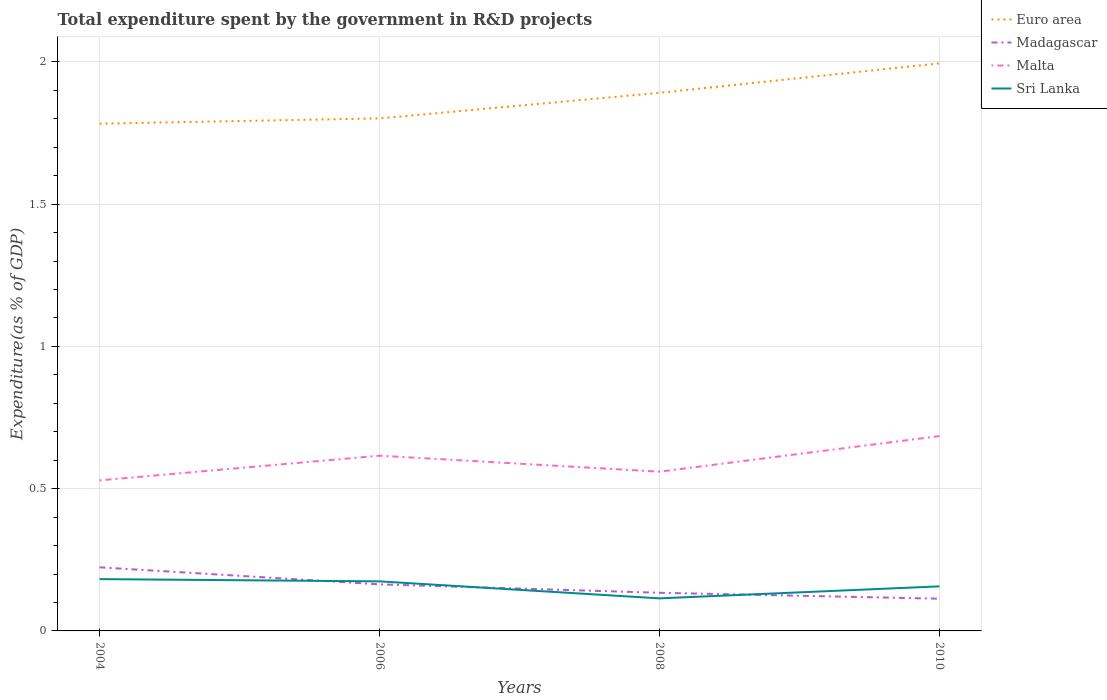Does the line corresponding to Malta intersect with the line corresponding to Madagascar?
Your response must be concise. No. Is the number of lines equal to the number of legend labels?
Provide a short and direct response. Yes. Across all years, what is the maximum total expenditure spent by the government in R&D projects in Malta?
Provide a short and direct response. 0.53. What is the total total expenditure spent by the government in R&D projects in Sri Lanka in the graph?
Offer a very short reply. 0.03. What is the difference between the highest and the second highest total expenditure spent by the government in R&D projects in Malta?
Provide a succinct answer. 0.16. What is the difference between the highest and the lowest total expenditure spent by the government in R&D projects in Madagascar?
Provide a succinct answer. 2. How many lines are there?
Provide a short and direct response. 4. What is the difference between two consecutive major ticks on the Y-axis?
Offer a terse response. 0.5. Are the values on the major ticks of Y-axis written in scientific E-notation?
Your answer should be very brief. No. Does the graph contain any zero values?
Your answer should be compact. No. Does the graph contain grids?
Your response must be concise. Yes. How many legend labels are there?
Make the answer very short. 4. What is the title of the graph?
Give a very brief answer. Total expenditure spent by the government in R&D projects. What is the label or title of the X-axis?
Provide a succinct answer. Years. What is the label or title of the Y-axis?
Provide a succinct answer. Expenditure(as % of GDP). What is the Expenditure(as % of GDP) of Euro area in 2004?
Make the answer very short. 1.78. What is the Expenditure(as % of GDP) in Madagascar in 2004?
Make the answer very short. 0.22. What is the Expenditure(as % of GDP) of Malta in 2004?
Make the answer very short. 0.53. What is the Expenditure(as % of GDP) in Sri Lanka in 2004?
Provide a succinct answer. 0.18. What is the Expenditure(as % of GDP) in Euro area in 2006?
Offer a terse response. 1.8. What is the Expenditure(as % of GDP) of Madagascar in 2006?
Your answer should be very brief. 0.16. What is the Expenditure(as % of GDP) of Malta in 2006?
Your answer should be compact. 0.62. What is the Expenditure(as % of GDP) of Sri Lanka in 2006?
Offer a very short reply. 0.17. What is the Expenditure(as % of GDP) in Euro area in 2008?
Offer a very short reply. 1.89. What is the Expenditure(as % of GDP) of Madagascar in 2008?
Your response must be concise. 0.13. What is the Expenditure(as % of GDP) in Malta in 2008?
Provide a short and direct response. 0.56. What is the Expenditure(as % of GDP) of Sri Lanka in 2008?
Offer a terse response. 0.11. What is the Expenditure(as % of GDP) of Euro area in 2010?
Offer a terse response. 1.99. What is the Expenditure(as % of GDP) of Madagascar in 2010?
Provide a succinct answer. 0.11. What is the Expenditure(as % of GDP) in Malta in 2010?
Offer a very short reply. 0.68. What is the Expenditure(as % of GDP) of Sri Lanka in 2010?
Offer a very short reply. 0.16. Across all years, what is the maximum Expenditure(as % of GDP) of Euro area?
Your answer should be very brief. 1.99. Across all years, what is the maximum Expenditure(as % of GDP) of Madagascar?
Provide a short and direct response. 0.22. Across all years, what is the maximum Expenditure(as % of GDP) in Malta?
Your answer should be compact. 0.68. Across all years, what is the maximum Expenditure(as % of GDP) in Sri Lanka?
Offer a terse response. 0.18. Across all years, what is the minimum Expenditure(as % of GDP) in Euro area?
Make the answer very short. 1.78. Across all years, what is the minimum Expenditure(as % of GDP) of Madagascar?
Your response must be concise. 0.11. Across all years, what is the minimum Expenditure(as % of GDP) of Malta?
Offer a very short reply. 0.53. Across all years, what is the minimum Expenditure(as % of GDP) of Sri Lanka?
Give a very brief answer. 0.11. What is the total Expenditure(as % of GDP) in Euro area in the graph?
Make the answer very short. 7.47. What is the total Expenditure(as % of GDP) of Madagascar in the graph?
Make the answer very short. 0.63. What is the total Expenditure(as % of GDP) in Malta in the graph?
Offer a terse response. 2.39. What is the total Expenditure(as % of GDP) of Sri Lanka in the graph?
Your answer should be compact. 0.63. What is the difference between the Expenditure(as % of GDP) of Euro area in 2004 and that in 2006?
Offer a very short reply. -0.02. What is the difference between the Expenditure(as % of GDP) in Madagascar in 2004 and that in 2006?
Your answer should be compact. 0.06. What is the difference between the Expenditure(as % of GDP) in Malta in 2004 and that in 2006?
Give a very brief answer. -0.09. What is the difference between the Expenditure(as % of GDP) of Sri Lanka in 2004 and that in 2006?
Offer a terse response. 0.01. What is the difference between the Expenditure(as % of GDP) of Euro area in 2004 and that in 2008?
Offer a terse response. -0.11. What is the difference between the Expenditure(as % of GDP) of Madagascar in 2004 and that in 2008?
Ensure brevity in your answer.  0.09. What is the difference between the Expenditure(as % of GDP) of Malta in 2004 and that in 2008?
Provide a succinct answer. -0.03. What is the difference between the Expenditure(as % of GDP) of Sri Lanka in 2004 and that in 2008?
Ensure brevity in your answer.  0.07. What is the difference between the Expenditure(as % of GDP) of Euro area in 2004 and that in 2010?
Make the answer very short. -0.21. What is the difference between the Expenditure(as % of GDP) of Madagascar in 2004 and that in 2010?
Make the answer very short. 0.11. What is the difference between the Expenditure(as % of GDP) of Malta in 2004 and that in 2010?
Offer a very short reply. -0.16. What is the difference between the Expenditure(as % of GDP) in Sri Lanka in 2004 and that in 2010?
Make the answer very short. 0.03. What is the difference between the Expenditure(as % of GDP) in Euro area in 2006 and that in 2008?
Your response must be concise. -0.09. What is the difference between the Expenditure(as % of GDP) in Madagascar in 2006 and that in 2008?
Provide a succinct answer. 0.03. What is the difference between the Expenditure(as % of GDP) in Malta in 2006 and that in 2008?
Give a very brief answer. 0.06. What is the difference between the Expenditure(as % of GDP) in Sri Lanka in 2006 and that in 2008?
Make the answer very short. 0.06. What is the difference between the Expenditure(as % of GDP) of Euro area in 2006 and that in 2010?
Offer a very short reply. -0.19. What is the difference between the Expenditure(as % of GDP) in Madagascar in 2006 and that in 2010?
Your answer should be very brief. 0.05. What is the difference between the Expenditure(as % of GDP) in Malta in 2006 and that in 2010?
Your answer should be very brief. -0.07. What is the difference between the Expenditure(as % of GDP) in Sri Lanka in 2006 and that in 2010?
Give a very brief answer. 0.02. What is the difference between the Expenditure(as % of GDP) of Euro area in 2008 and that in 2010?
Provide a succinct answer. -0.1. What is the difference between the Expenditure(as % of GDP) of Madagascar in 2008 and that in 2010?
Your response must be concise. 0.02. What is the difference between the Expenditure(as % of GDP) in Malta in 2008 and that in 2010?
Give a very brief answer. -0.13. What is the difference between the Expenditure(as % of GDP) of Sri Lanka in 2008 and that in 2010?
Ensure brevity in your answer.  -0.04. What is the difference between the Expenditure(as % of GDP) of Euro area in 2004 and the Expenditure(as % of GDP) of Madagascar in 2006?
Your answer should be very brief. 1.62. What is the difference between the Expenditure(as % of GDP) of Euro area in 2004 and the Expenditure(as % of GDP) of Malta in 2006?
Ensure brevity in your answer.  1.17. What is the difference between the Expenditure(as % of GDP) in Euro area in 2004 and the Expenditure(as % of GDP) in Sri Lanka in 2006?
Offer a very short reply. 1.61. What is the difference between the Expenditure(as % of GDP) in Madagascar in 2004 and the Expenditure(as % of GDP) in Malta in 2006?
Provide a succinct answer. -0.39. What is the difference between the Expenditure(as % of GDP) in Madagascar in 2004 and the Expenditure(as % of GDP) in Sri Lanka in 2006?
Give a very brief answer. 0.05. What is the difference between the Expenditure(as % of GDP) in Malta in 2004 and the Expenditure(as % of GDP) in Sri Lanka in 2006?
Your answer should be compact. 0.35. What is the difference between the Expenditure(as % of GDP) of Euro area in 2004 and the Expenditure(as % of GDP) of Madagascar in 2008?
Ensure brevity in your answer.  1.65. What is the difference between the Expenditure(as % of GDP) of Euro area in 2004 and the Expenditure(as % of GDP) of Malta in 2008?
Keep it short and to the point. 1.22. What is the difference between the Expenditure(as % of GDP) of Euro area in 2004 and the Expenditure(as % of GDP) of Sri Lanka in 2008?
Offer a very short reply. 1.67. What is the difference between the Expenditure(as % of GDP) in Madagascar in 2004 and the Expenditure(as % of GDP) in Malta in 2008?
Your answer should be very brief. -0.34. What is the difference between the Expenditure(as % of GDP) in Madagascar in 2004 and the Expenditure(as % of GDP) in Sri Lanka in 2008?
Ensure brevity in your answer.  0.11. What is the difference between the Expenditure(as % of GDP) of Malta in 2004 and the Expenditure(as % of GDP) of Sri Lanka in 2008?
Make the answer very short. 0.41. What is the difference between the Expenditure(as % of GDP) in Euro area in 2004 and the Expenditure(as % of GDP) in Madagascar in 2010?
Offer a terse response. 1.67. What is the difference between the Expenditure(as % of GDP) of Euro area in 2004 and the Expenditure(as % of GDP) of Malta in 2010?
Keep it short and to the point. 1.1. What is the difference between the Expenditure(as % of GDP) in Euro area in 2004 and the Expenditure(as % of GDP) in Sri Lanka in 2010?
Provide a short and direct response. 1.63. What is the difference between the Expenditure(as % of GDP) of Madagascar in 2004 and the Expenditure(as % of GDP) of Malta in 2010?
Offer a terse response. -0.46. What is the difference between the Expenditure(as % of GDP) of Madagascar in 2004 and the Expenditure(as % of GDP) of Sri Lanka in 2010?
Keep it short and to the point. 0.07. What is the difference between the Expenditure(as % of GDP) in Malta in 2004 and the Expenditure(as % of GDP) in Sri Lanka in 2010?
Offer a terse response. 0.37. What is the difference between the Expenditure(as % of GDP) in Euro area in 2006 and the Expenditure(as % of GDP) in Madagascar in 2008?
Keep it short and to the point. 1.67. What is the difference between the Expenditure(as % of GDP) of Euro area in 2006 and the Expenditure(as % of GDP) of Malta in 2008?
Give a very brief answer. 1.24. What is the difference between the Expenditure(as % of GDP) of Euro area in 2006 and the Expenditure(as % of GDP) of Sri Lanka in 2008?
Your answer should be very brief. 1.69. What is the difference between the Expenditure(as % of GDP) in Madagascar in 2006 and the Expenditure(as % of GDP) in Malta in 2008?
Your answer should be very brief. -0.4. What is the difference between the Expenditure(as % of GDP) in Madagascar in 2006 and the Expenditure(as % of GDP) in Sri Lanka in 2008?
Your answer should be very brief. 0.05. What is the difference between the Expenditure(as % of GDP) in Malta in 2006 and the Expenditure(as % of GDP) in Sri Lanka in 2008?
Make the answer very short. 0.5. What is the difference between the Expenditure(as % of GDP) in Euro area in 2006 and the Expenditure(as % of GDP) in Madagascar in 2010?
Make the answer very short. 1.69. What is the difference between the Expenditure(as % of GDP) in Euro area in 2006 and the Expenditure(as % of GDP) in Malta in 2010?
Give a very brief answer. 1.12. What is the difference between the Expenditure(as % of GDP) of Euro area in 2006 and the Expenditure(as % of GDP) of Sri Lanka in 2010?
Provide a succinct answer. 1.64. What is the difference between the Expenditure(as % of GDP) in Madagascar in 2006 and the Expenditure(as % of GDP) in Malta in 2010?
Your answer should be compact. -0.52. What is the difference between the Expenditure(as % of GDP) of Madagascar in 2006 and the Expenditure(as % of GDP) of Sri Lanka in 2010?
Ensure brevity in your answer.  0.01. What is the difference between the Expenditure(as % of GDP) of Malta in 2006 and the Expenditure(as % of GDP) of Sri Lanka in 2010?
Offer a very short reply. 0.46. What is the difference between the Expenditure(as % of GDP) of Euro area in 2008 and the Expenditure(as % of GDP) of Madagascar in 2010?
Give a very brief answer. 1.78. What is the difference between the Expenditure(as % of GDP) of Euro area in 2008 and the Expenditure(as % of GDP) of Malta in 2010?
Your answer should be very brief. 1.21. What is the difference between the Expenditure(as % of GDP) of Euro area in 2008 and the Expenditure(as % of GDP) of Sri Lanka in 2010?
Give a very brief answer. 1.73. What is the difference between the Expenditure(as % of GDP) in Madagascar in 2008 and the Expenditure(as % of GDP) in Malta in 2010?
Offer a terse response. -0.55. What is the difference between the Expenditure(as % of GDP) of Madagascar in 2008 and the Expenditure(as % of GDP) of Sri Lanka in 2010?
Ensure brevity in your answer.  -0.02. What is the difference between the Expenditure(as % of GDP) of Malta in 2008 and the Expenditure(as % of GDP) of Sri Lanka in 2010?
Ensure brevity in your answer.  0.4. What is the average Expenditure(as % of GDP) of Euro area per year?
Provide a short and direct response. 1.87. What is the average Expenditure(as % of GDP) of Madagascar per year?
Make the answer very short. 0.16. What is the average Expenditure(as % of GDP) of Malta per year?
Ensure brevity in your answer.  0.6. What is the average Expenditure(as % of GDP) of Sri Lanka per year?
Your response must be concise. 0.16. In the year 2004, what is the difference between the Expenditure(as % of GDP) of Euro area and Expenditure(as % of GDP) of Madagascar?
Your response must be concise. 1.56. In the year 2004, what is the difference between the Expenditure(as % of GDP) in Euro area and Expenditure(as % of GDP) in Malta?
Your answer should be very brief. 1.25. In the year 2004, what is the difference between the Expenditure(as % of GDP) in Euro area and Expenditure(as % of GDP) in Sri Lanka?
Provide a succinct answer. 1.6. In the year 2004, what is the difference between the Expenditure(as % of GDP) of Madagascar and Expenditure(as % of GDP) of Malta?
Your answer should be compact. -0.31. In the year 2004, what is the difference between the Expenditure(as % of GDP) in Madagascar and Expenditure(as % of GDP) in Sri Lanka?
Offer a terse response. 0.04. In the year 2004, what is the difference between the Expenditure(as % of GDP) in Malta and Expenditure(as % of GDP) in Sri Lanka?
Provide a short and direct response. 0.35. In the year 2006, what is the difference between the Expenditure(as % of GDP) in Euro area and Expenditure(as % of GDP) in Madagascar?
Keep it short and to the point. 1.64. In the year 2006, what is the difference between the Expenditure(as % of GDP) of Euro area and Expenditure(as % of GDP) of Malta?
Keep it short and to the point. 1.19. In the year 2006, what is the difference between the Expenditure(as % of GDP) of Euro area and Expenditure(as % of GDP) of Sri Lanka?
Provide a short and direct response. 1.63. In the year 2006, what is the difference between the Expenditure(as % of GDP) in Madagascar and Expenditure(as % of GDP) in Malta?
Your answer should be compact. -0.45. In the year 2006, what is the difference between the Expenditure(as % of GDP) of Madagascar and Expenditure(as % of GDP) of Sri Lanka?
Provide a succinct answer. -0.01. In the year 2006, what is the difference between the Expenditure(as % of GDP) of Malta and Expenditure(as % of GDP) of Sri Lanka?
Offer a terse response. 0.44. In the year 2008, what is the difference between the Expenditure(as % of GDP) in Euro area and Expenditure(as % of GDP) in Madagascar?
Your response must be concise. 1.76. In the year 2008, what is the difference between the Expenditure(as % of GDP) of Euro area and Expenditure(as % of GDP) of Malta?
Give a very brief answer. 1.33. In the year 2008, what is the difference between the Expenditure(as % of GDP) in Euro area and Expenditure(as % of GDP) in Sri Lanka?
Give a very brief answer. 1.78. In the year 2008, what is the difference between the Expenditure(as % of GDP) of Madagascar and Expenditure(as % of GDP) of Malta?
Provide a short and direct response. -0.43. In the year 2008, what is the difference between the Expenditure(as % of GDP) in Madagascar and Expenditure(as % of GDP) in Sri Lanka?
Ensure brevity in your answer.  0.02. In the year 2008, what is the difference between the Expenditure(as % of GDP) in Malta and Expenditure(as % of GDP) in Sri Lanka?
Make the answer very short. 0.45. In the year 2010, what is the difference between the Expenditure(as % of GDP) in Euro area and Expenditure(as % of GDP) in Madagascar?
Your response must be concise. 1.88. In the year 2010, what is the difference between the Expenditure(as % of GDP) in Euro area and Expenditure(as % of GDP) in Malta?
Your response must be concise. 1.31. In the year 2010, what is the difference between the Expenditure(as % of GDP) in Euro area and Expenditure(as % of GDP) in Sri Lanka?
Make the answer very short. 1.84. In the year 2010, what is the difference between the Expenditure(as % of GDP) of Madagascar and Expenditure(as % of GDP) of Malta?
Your response must be concise. -0.57. In the year 2010, what is the difference between the Expenditure(as % of GDP) in Madagascar and Expenditure(as % of GDP) in Sri Lanka?
Provide a short and direct response. -0.04. In the year 2010, what is the difference between the Expenditure(as % of GDP) in Malta and Expenditure(as % of GDP) in Sri Lanka?
Provide a short and direct response. 0.53. What is the ratio of the Expenditure(as % of GDP) in Madagascar in 2004 to that in 2006?
Give a very brief answer. 1.37. What is the ratio of the Expenditure(as % of GDP) in Malta in 2004 to that in 2006?
Ensure brevity in your answer.  0.86. What is the ratio of the Expenditure(as % of GDP) in Sri Lanka in 2004 to that in 2006?
Your answer should be very brief. 1.05. What is the ratio of the Expenditure(as % of GDP) in Euro area in 2004 to that in 2008?
Your response must be concise. 0.94. What is the ratio of the Expenditure(as % of GDP) of Madagascar in 2004 to that in 2008?
Ensure brevity in your answer.  1.67. What is the ratio of the Expenditure(as % of GDP) in Malta in 2004 to that in 2008?
Provide a succinct answer. 0.95. What is the ratio of the Expenditure(as % of GDP) of Sri Lanka in 2004 to that in 2008?
Your answer should be very brief. 1.59. What is the ratio of the Expenditure(as % of GDP) of Euro area in 2004 to that in 2010?
Offer a terse response. 0.89. What is the ratio of the Expenditure(as % of GDP) of Madagascar in 2004 to that in 2010?
Your response must be concise. 1.97. What is the ratio of the Expenditure(as % of GDP) of Malta in 2004 to that in 2010?
Ensure brevity in your answer.  0.77. What is the ratio of the Expenditure(as % of GDP) in Sri Lanka in 2004 to that in 2010?
Your answer should be compact. 1.16. What is the ratio of the Expenditure(as % of GDP) of Euro area in 2006 to that in 2008?
Provide a succinct answer. 0.95. What is the ratio of the Expenditure(as % of GDP) in Madagascar in 2006 to that in 2008?
Your answer should be compact. 1.22. What is the ratio of the Expenditure(as % of GDP) in Malta in 2006 to that in 2008?
Offer a very short reply. 1.1. What is the ratio of the Expenditure(as % of GDP) of Sri Lanka in 2006 to that in 2008?
Keep it short and to the point. 1.52. What is the ratio of the Expenditure(as % of GDP) of Euro area in 2006 to that in 2010?
Your answer should be compact. 0.9. What is the ratio of the Expenditure(as % of GDP) of Madagascar in 2006 to that in 2010?
Offer a very short reply. 1.45. What is the ratio of the Expenditure(as % of GDP) in Malta in 2006 to that in 2010?
Offer a terse response. 0.9. What is the ratio of the Expenditure(as % of GDP) of Sri Lanka in 2006 to that in 2010?
Provide a short and direct response. 1.11. What is the ratio of the Expenditure(as % of GDP) of Euro area in 2008 to that in 2010?
Offer a terse response. 0.95. What is the ratio of the Expenditure(as % of GDP) of Madagascar in 2008 to that in 2010?
Your answer should be compact. 1.18. What is the ratio of the Expenditure(as % of GDP) in Malta in 2008 to that in 2010?
Give a very brief answer. 0.82. What is the ratio of the Expenditure(as % of GDP) in Sri Lanka in 2008 to that in 2010?
Your response must be concise. 0.73. What is the difference between the highest and the second highest Expenditure(as % of GDP) of Euro area?
Provide a short and direct response. 0.1. What is the difference between the highest and the second highest Expenditure(as % of GDP) of Madagascar?
Provide a succinct answer. 0.06. What is the difference between the highest and the second highest Expenditure(as % of GDP) in Malta?
Make the answer very short. 0.07. What is the difference between the highest and the second highest Expenditure(as % of GDP) in Sri Lanka?
Give a very brief answer. 0.01. What is the difference between the highest and the lowest Expenditure(as % of GDP) in Euro area?
Your answer should be compact. 0.21. What is the difference between the highest and the lowest Expenditure(as % of GDP) in Madagascar?
Keep it short and to the point. 0.11. What is the difference between the highest and the lowest Expenditure(as % of GDP) in Malta?
Your answer should be very brief. 0.16. What is the difference between the highest and the lowest Expenditure(as % of GDP) of Sri Lanka?
Offer a very short reply. 0.07. 